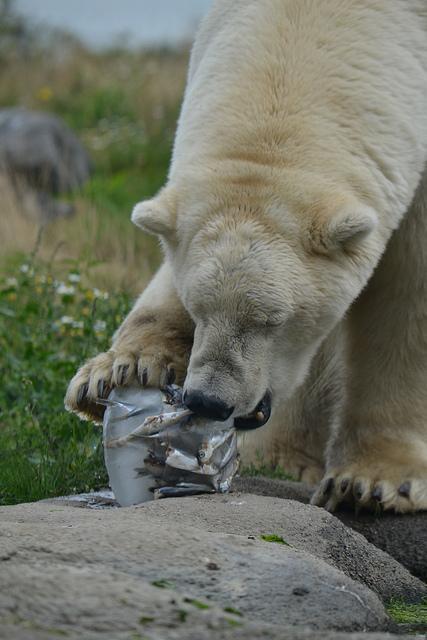How many bears are in the photo?
Give a very brief answer. 1. 